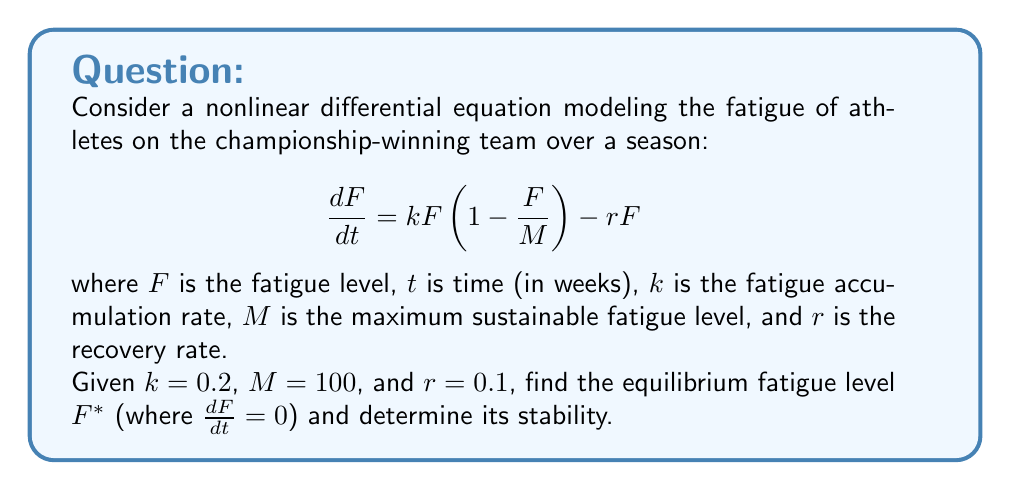Help me with this question. 1) To find the equilibrium point, set $\frac{dF}{dt} = 0$:

   $$0 = kF(1-\frac{F}{M}) - rF$$

2) Substitute the given values:

   $$0 = 0.2F(1-\frac{F}{100}) - 0.1F$$

3) Simplify:

   $$0 = 0.2F - 0.002F^2 - 0.1F = 0.1F - 0.002F^2$$

4) Factor out F:

   $$F(0.1 - 0.002F) = 0$$

5) Solve for F:

   $F = 0$ or $0.1 - 0.002F = 0$
   
   From the second equation: $F = 50$

6) The equilibrium points are $F^* = 0$ and $F^* = 50$

7) To determine stability, examine $\frac{d}{dF}(\frac{dF}{dt})$ at each equilibrium point:

   $$\frac{d}{dF}(\frac{dF}{dt}) = k(1-\frac{2F}{M}) - r = 0.2(1-\frac{2F}{100}) - 0.1$$

8) At $F^* = 0$:
   
   $$0.2(1-\frac{2(0)}{100}) - 0.1 = 0.1 > 0$$

   This is unstable.

9) At $F^* = 50$:
   
   $$0.2(1-\frac{2(50)}{100}) - 0.1 = -0.1 < 0$$

   This is stable.

Therefore, $F^* = 50$ is the stable equilibrium fatigue level.
Answer: $F^* = 50$ (stable equilibrium) 